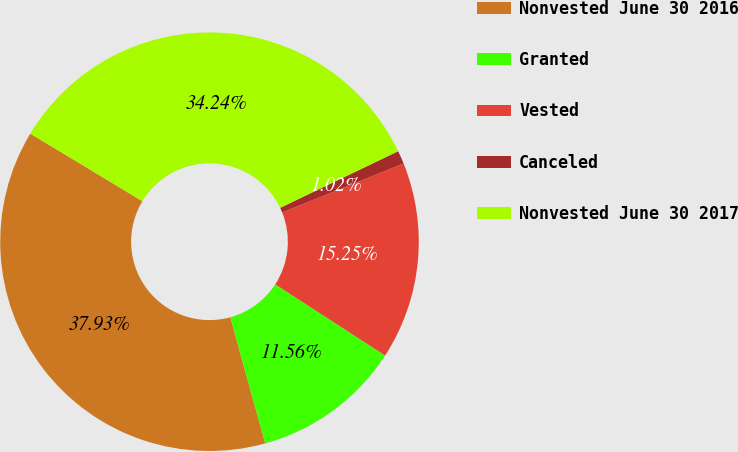Convert chart. <chart><loc_0><loc_0><loc_500><loc_500><pie_chart><fcel>Nonvested June 30 2016<fcel>Granted<fcel>Vested<fcel>Canceled<fcel>Nonvested June 30 2017<nl><fcel>37.93%<fcel>11.56%<fcel>15.25%<fcel>1.02%<fcel>34.24%<nl></chart> 